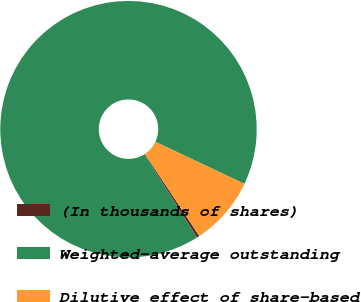<chart> <loc_0><loc_0><loc_500><loc_500><pie_chart><fcel>(In thousands of shares)<fcel>Weighted-average outstanding<fcel>Dilutive effect of share-based<nl><fcel>0.33%<fcel>90.99%<fcel>8.67%<nl></chart> 